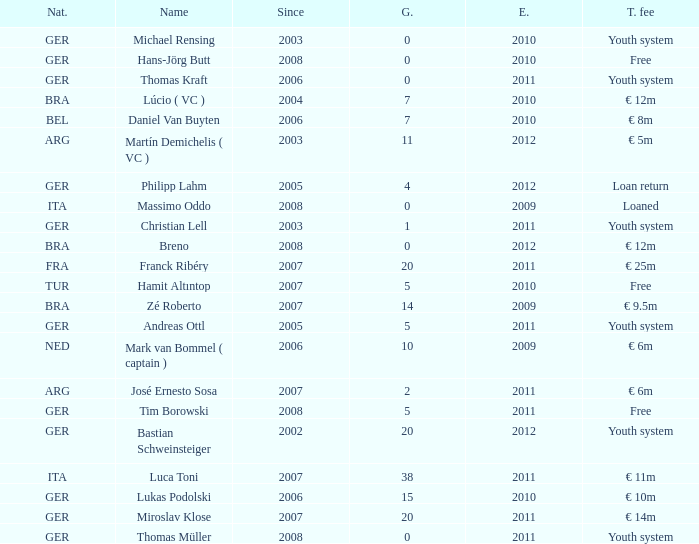What is the lowest year in since that had a transfer fee of € 14m and ended after 2011? None. 